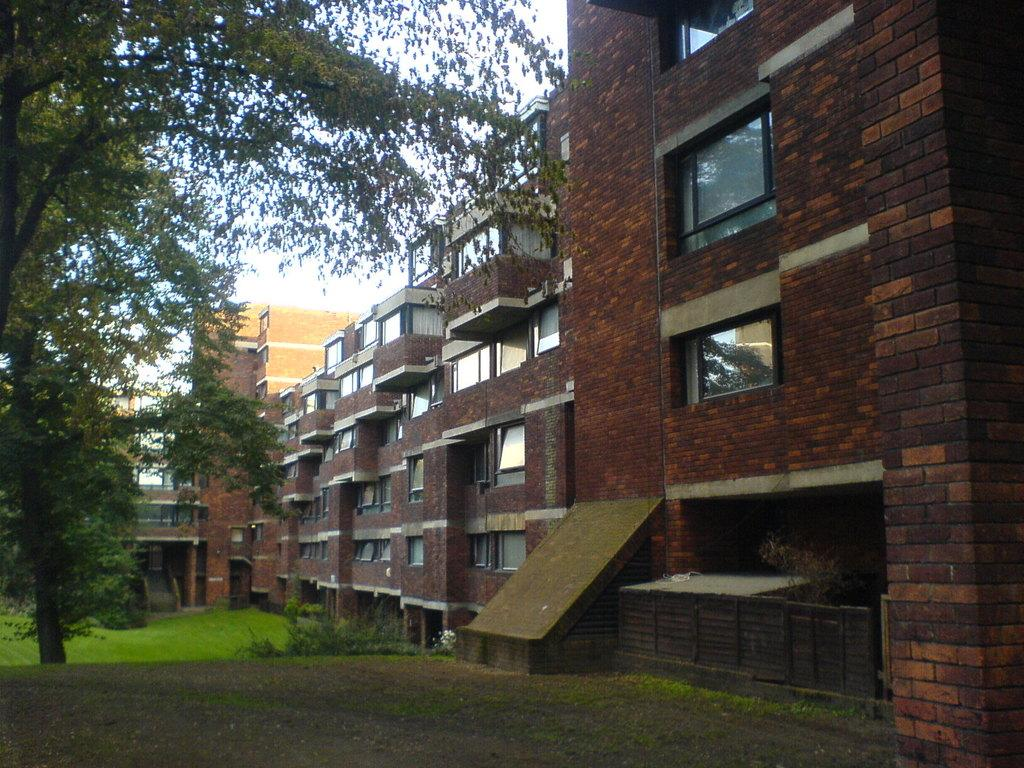What type of structures can be seen in the image? There are buildings in the image. What is present on the ground in front of the buildings? There is grass on the surface in front of the building. Are there any plants or vegetation in the image? Yes, there is a tree in the image. What type of meat is hanging from the tree in the image? There is no meat present in the image; it features a tree and buildings. What role does the father play in the image? There is no reference to a father or any people in the image. 